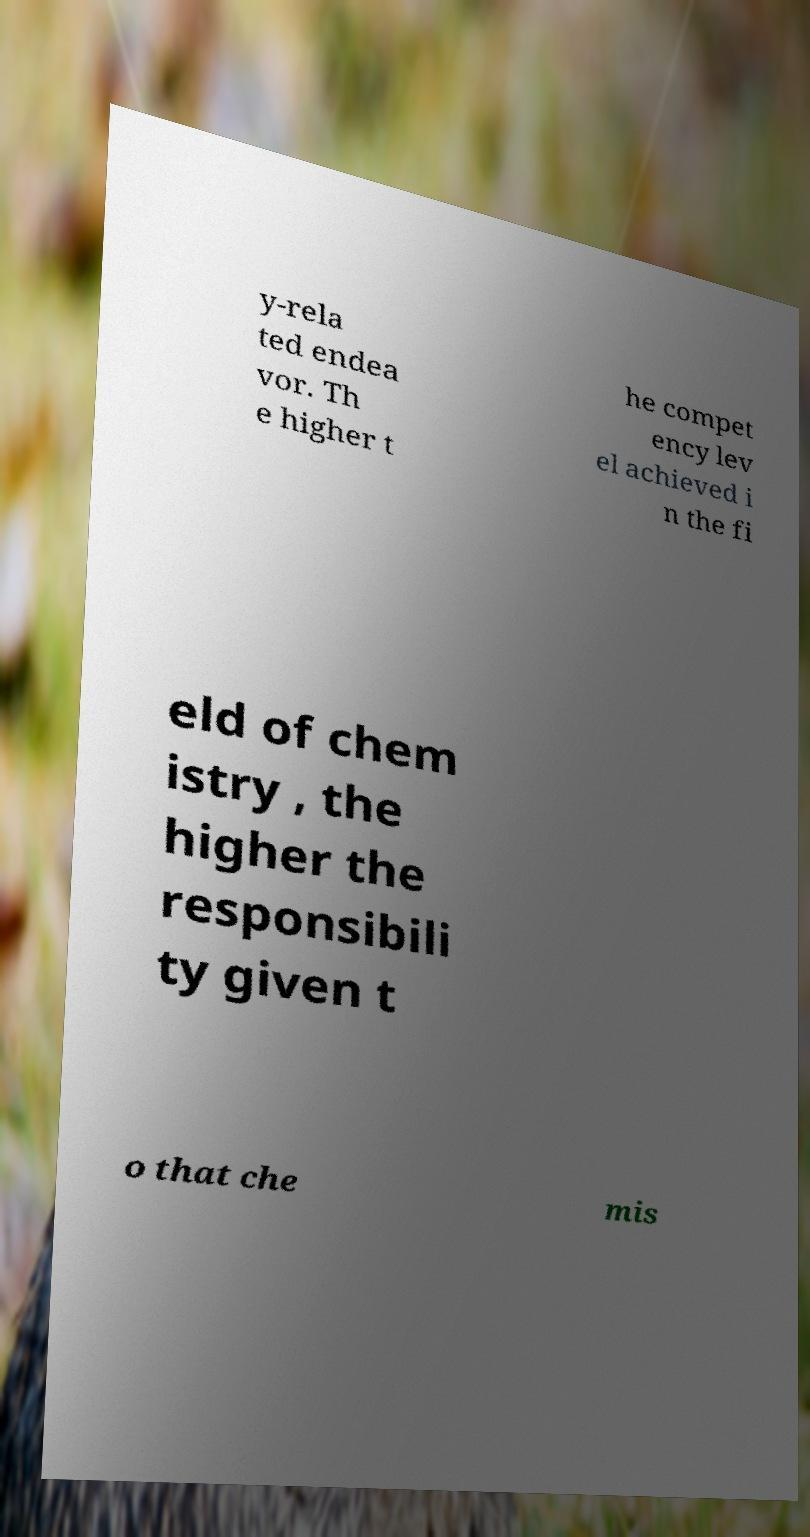For documentation purposes, I need the text within this image transcribed. Could you provide that? y-rela ted endea vor. Th e higher t he compet ency lev el achieved i n the fi eld of chem istry , the higher the responsibili ty given t o that che mis 